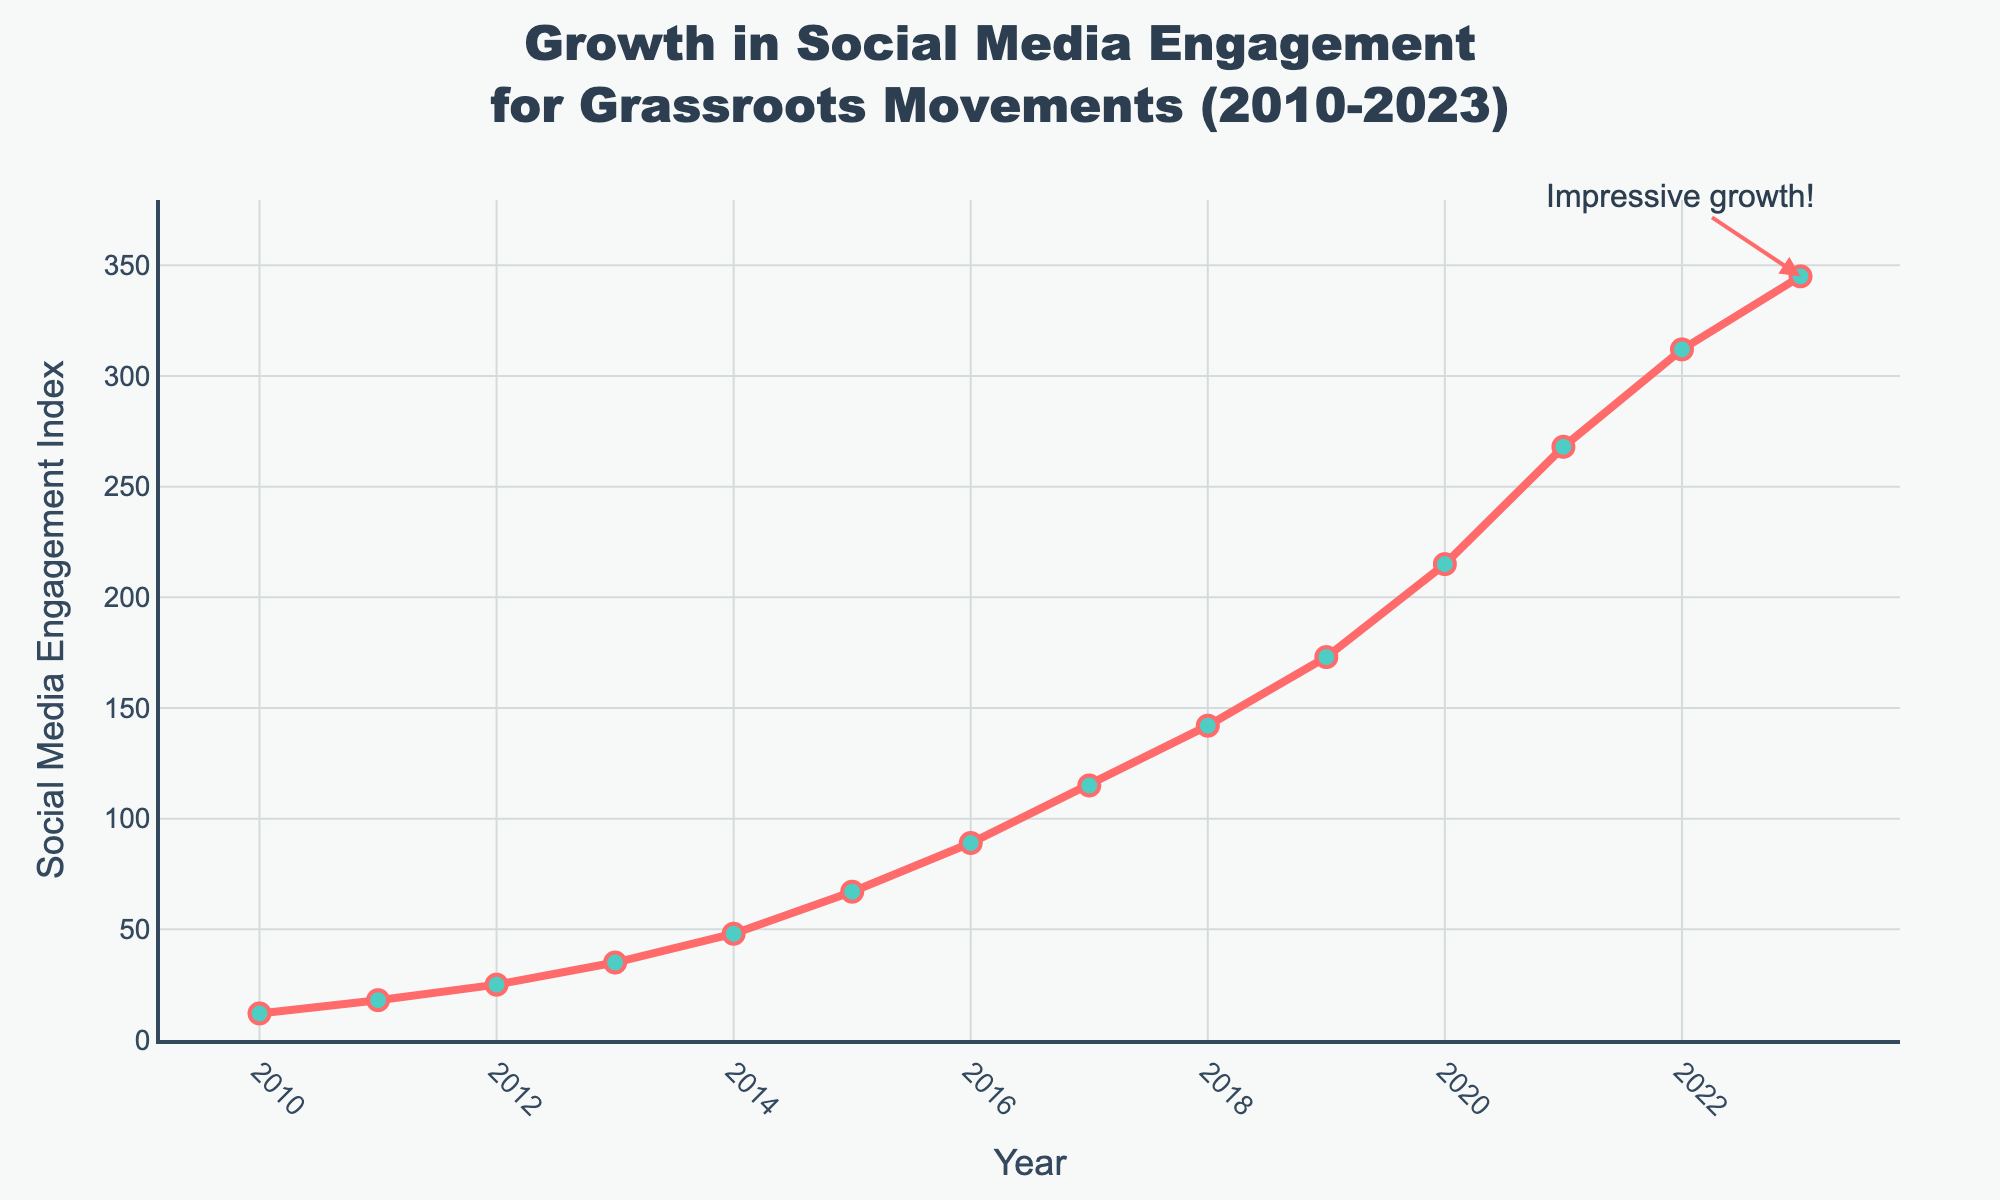What was the Social Media Engagement Index in 2010? The Social Media Engagement Index for 2010 is stated at the beginning of the data list and marked on the chart.
Answer: 12 What is the difference in Social Media Engagement Index between 2023 and 2010? To find the difference, subtract the 2010 value from the 2023 value (345 - 12).
Answer: 333 How much did the Social Media Engagement Index increase from 2016 to 2017? Subtract the 2016 value from the 2017 value (115 - 89).
Answer: 26 What is the average Social Media Engagement Index for the years 2010 to 2015? Add the values from 2010 to 2015 and divide by the number of years ((12 + 18 + 25 + 35 + 48 + 67) / 6).
Answer: 34.17 In which year did the Social Media Engagement Index surpass 100 for the first time? Identify the first year in the sequence where the Index exceeds 100; it is 2017.
Answer: 2017 By how much did the Social Media Engagement Index grow from 2020 to 2021 in terms of percentage? Calculate the difference (268 - 215), divide by the 2020 value (53 / 215), and multiply by 100 to get the percentage.
Answer: 24.65% What is the slope of the trend line from 2010 to 2023? The slope can be calculated by the formula (change in y / change in x), which is (345 - 12) / (2023 - 2010).
Answer: 25.57 Which year had the highest increase in Social Media Engagement Index when compared to the previous year? Compare the year-over-year increase values and identify the largest one which occurs from 2021 to 2022 (312 - 268 = 44).
Answer: 2022 What is the median Social Media Engagement Index value from 2010 to 2023? To find the median, order the values and identify the middle one, which is the 7th value in this ordered list (0-based index): (12, 18, 25, 35, 48, 67, 89, 115, 142, 173, 215, 268, 312, 345). The median is 102.
Answer: 102 What is visually notable about the Social Media Engagement Index in recent years? The index shows a continuous and significant increase, especially from 2020 to 2023, highlighted by the marked annotation "Impressive growth!".
Answer: Continuous increase 